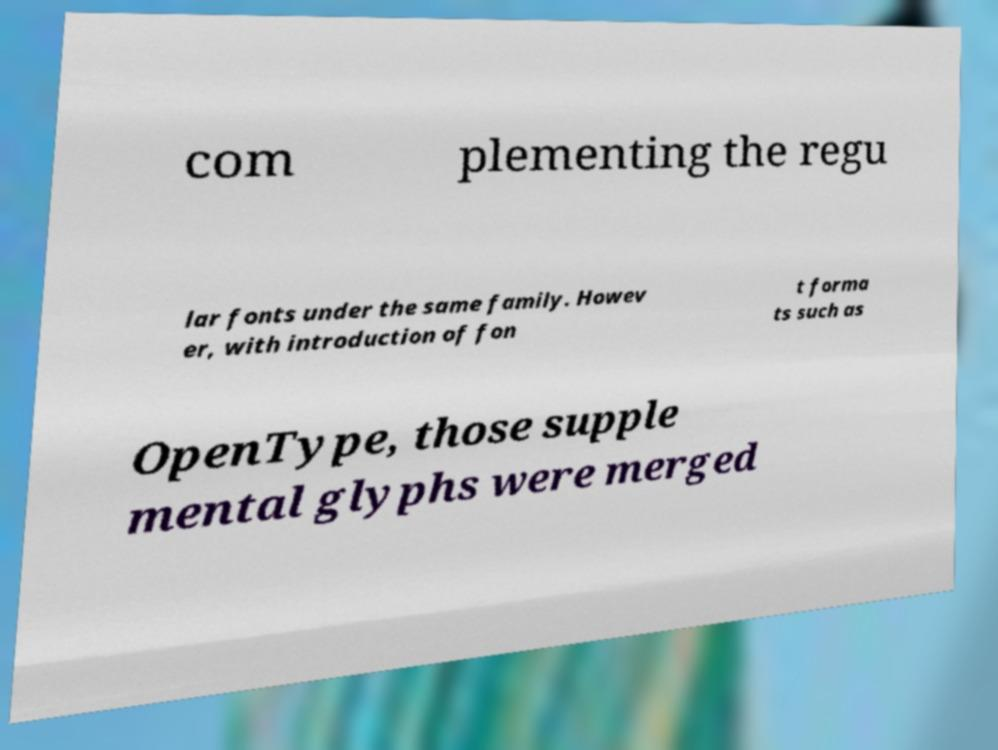Can you accurately transcribe the text from the provided image for me? com plementing the regu lar fonts under the same family. Howev er, with introduction of fon t forma ts such as OpenType, those supple mental glyphs were merged 